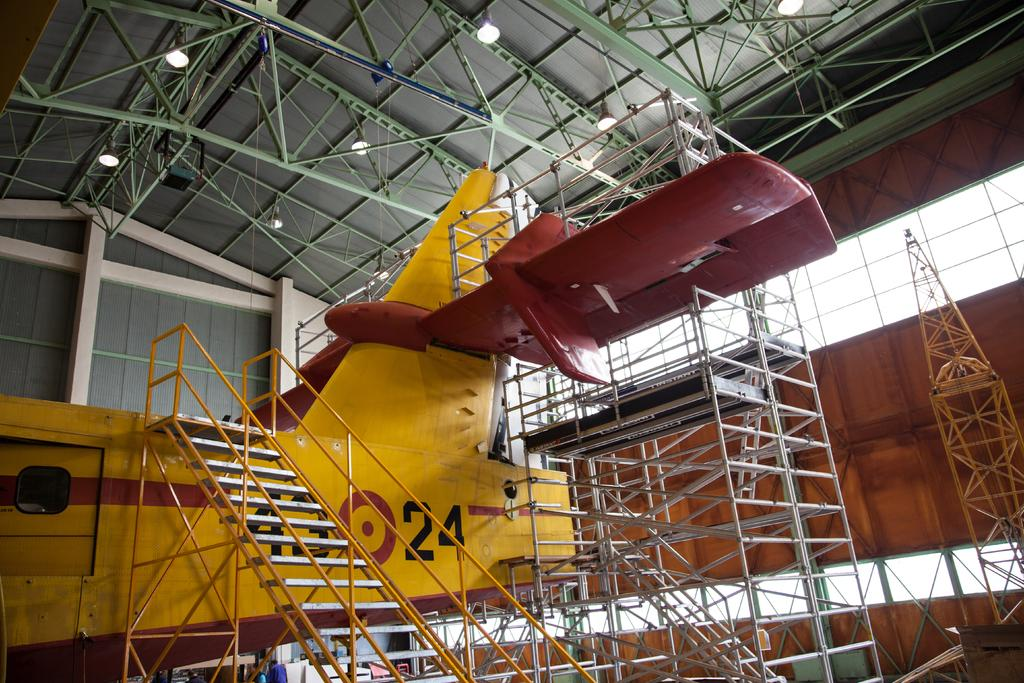<image>
Relay a brief, clear account of the picture shown. a plane with the number 24 written on the side 